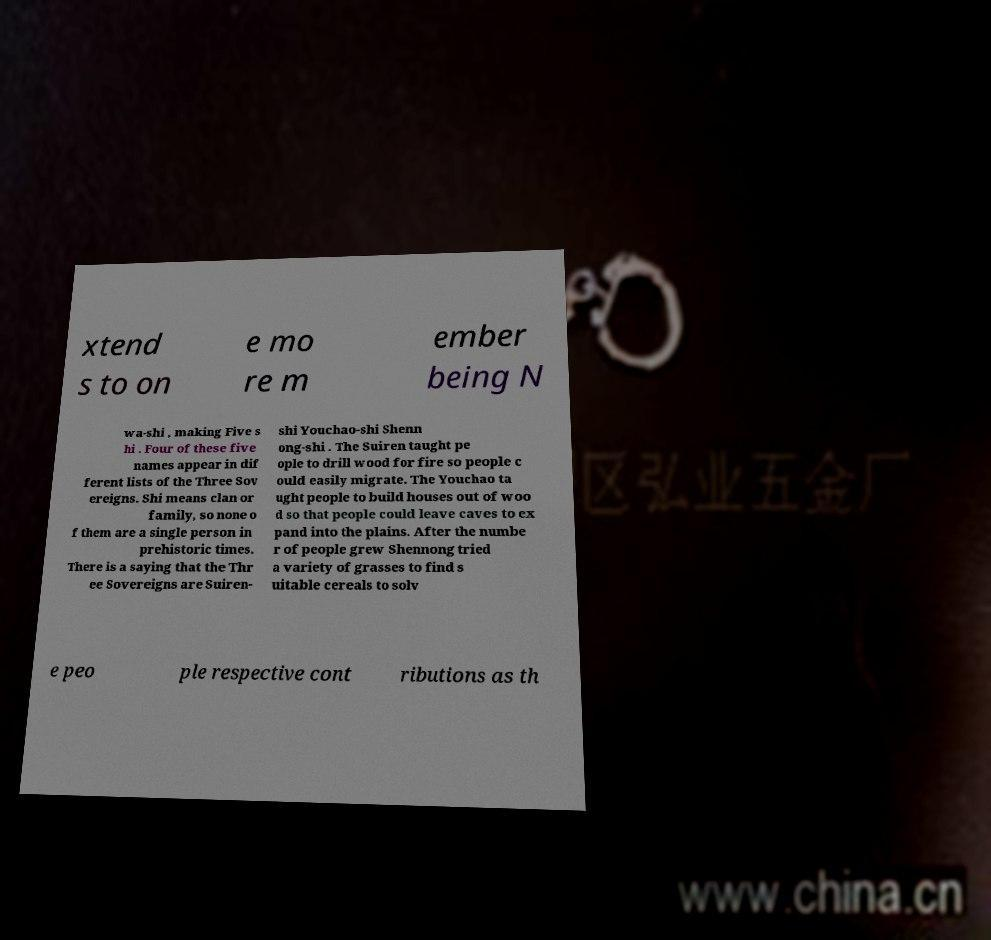Could you assist in decoding the text presented in this image and type it out clearly? xtend s to on e mo re m ember being N wa-shi , making Five s hi . Four of these five names appear in dif ferent lists of the Three Sov ereigns. Shi means clan or family, so none o f them are a single person in prehistoric times. There is a saying that the Thr ee Sovereigns are Suiren- shi Youchao-shi Shenn ong-shi . The Suiren taught pe ople to drill wood for fire so people c ould easily migrate. The Youchao ta ught people to build houses out of woo d so that people could leave caves to ex pand into the plains. After the numbe r of people grew Shennong tried a variety of grasses to find s uitable cereals to solv e peo ple respective cont ributions as th 